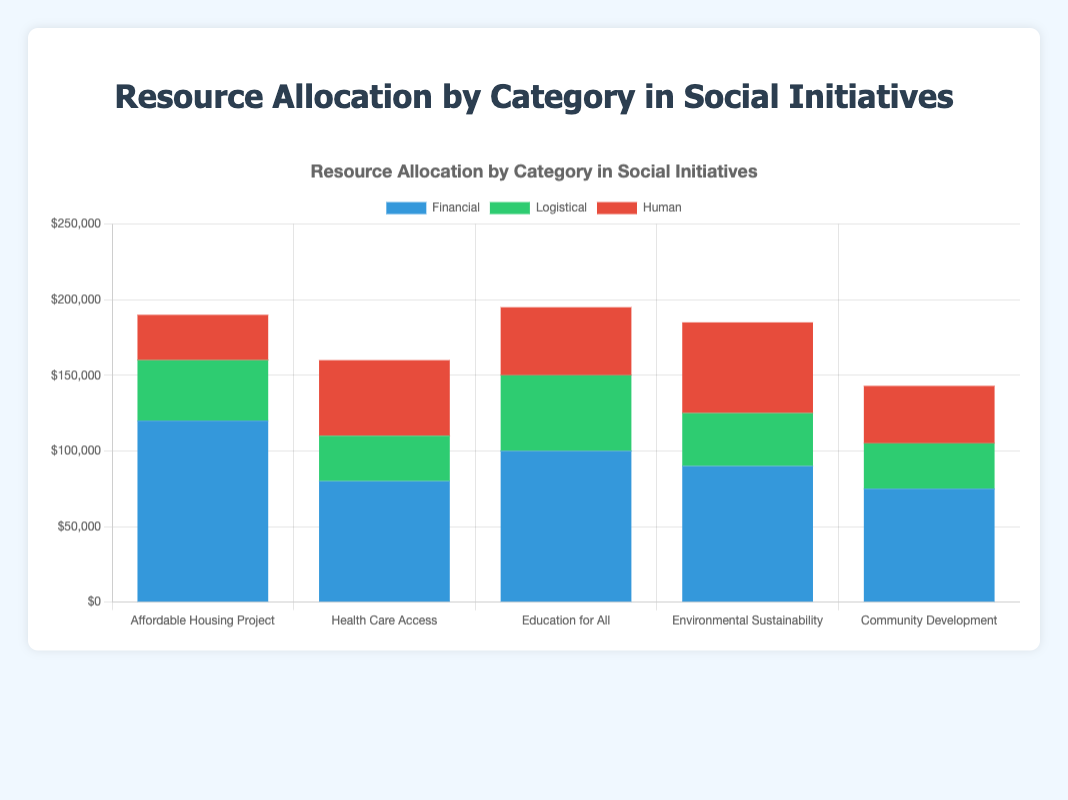What is the total amount allocated to the Affordable Housing Project? The Affordable Housing Project has three categories: Financial ($120,000), Logistical ($40,000), and Human ($30,000). The total amount allocated is the sum of these three values: $120,000 + $40,000 + $30,000.
Answer: $190,000 Which initiative has the highest financial allocation? By comparing the financial amounts allocated to each initiative, we see that the Affordable Housing Project has the highest financial allocation with $120,000.
Answer: Affordable Housing Project How does the logistical allocation for Community Development compare with that for Health Care Access? The logistical allocation for Community Development is $30,000, which is the same amount as that allocated to Health Care Access.
Answer: Equal What is the difference between the human resource allocations of Environmental Sustainability and Education for All? Environmental Sustainability has $60,000 allocated for Human resources, while Education for All has $45,000. The difference is $60,000 - $45,000.
Answer: $15,000 How much more is allocated to Financial resources compared to Logistical resources for all initiatives combined? Total Financial resources: $120,000 + $80,000 + $100,000 + $90,000 + $75,000 = $465,000. Total Logistical resources: $40,000 + $30,000 + $50,000 + $35,000 + $30,000 = $185,000. The difference is $465,000 - $185,000.
Answer: $280,000 